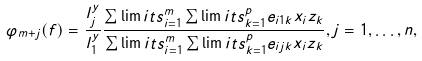<formula> <loc_0><loc_0><loc_500><loc_500>\varphi _ { m + j } ( f ) = \frac { l _ { j } ^ { y } } { l _ { 1 } ^ { y } } \frac { \sum \lim i t s _ { i = 1 } ^ { m } \sum \lim i t s _ { k = 1 } ^ { p } { e _ { i 1 k } x _ { i } z _ { k } } } { \sum \lim i t s _ { i = 1 } ^ { m } \sum \lim i t s _ { k = 1 } ^ { p } { e _ { i j k } x _ { i } z _ { k } } } , j = 1 , \mathellipsis , n ,</formula> 